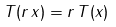Convert formula to latex. <formula><loc_0><loc_0><loc_500><loc_500>T ( r \, x ) = r \, T ( x )</formula> 